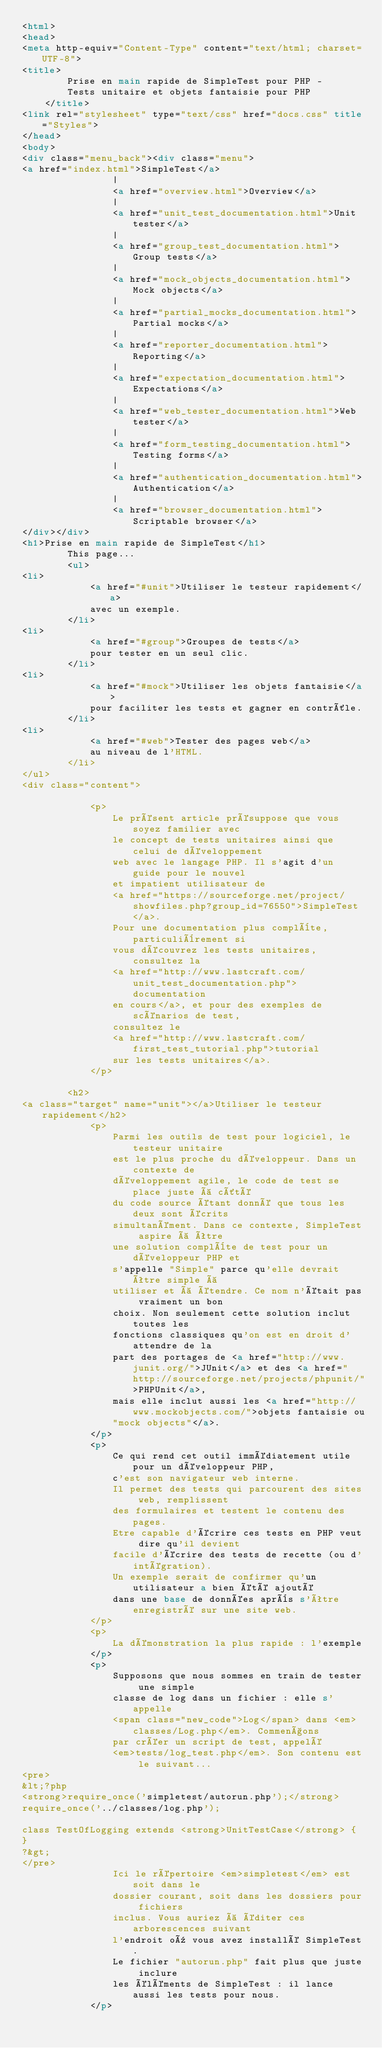Convert code to text. <code><loc_0><loc_0><loc_500><loc_500><_HTML_><html>
<head>
<meta http-equiv="Content-Type" content="text/html; charset=UTF-8">
<title>
        Prise en main rapide de SimpleTest pour PHP -
        Tests unitaire et objets fantaisie pour PHP
    </title>
<link rel="stylesheet" type="text/css" href="docs.css" title="Styles">
</head>
<body>
<div class="menu_back"><div class="menu">
<a href="index.html">SimpleTest</a>
                |
                <a href="overview.html">Overview</a>
                |
                <a href="unit_test_documentation.html">Unit tester</a>
                |
                <a href="group_test_documentation.html">Group tests</a>
                |
                <a href="mock_objects_documentation.html">Mock objects</a>
                |
                <a href="partial_mocks_documentation.html">Partial mocks</a>
                |
                <a href="reporter_documentation.html">Reporting</a>
                |
                <a href="expectation_documentation.html">Expectations</a>
                |
                <a href="web_tester_documentation.html">Web tester</a>
                |
                <a href="form_testing_documentation.html">Testing forms</a>
                |
                <a href="authentication_documentation.html">Authentication</a>
                |
                <a href="browser_documentation.html">Scriptable browser</a>
</div></div>
<h1>Prise en main rapide de SimpleTest</h1>
        This page...
        <ul>
<li>
            <a href="#unit">Utiliser le testeur rapidement</a>
            avec un exemple.
        </li>
<li>
            <a href="#group">Groupes de tests</a>
            pour tester en un seul clic.
        </li>
<li>
            <a href="#mock">Utiliser les objets fantaisie</a>
            pour faciliter les tests et gagner en contrôle.
        </li>
<li>
            <a href="#web">Tester des pages web</a>
            au niveau de l'HTML.
        </li>
</ul>
<div class="content">
        
            <p>
                Le présent article présuppose que vous soyez familier avec
                le concept de tests unitaires ainsi que celui de développement
                web avec le langage PHP. Il s'agit d'un guide pour le nouvel
                et impatient utilisateur de
                <a href="https://sourceforge.net/project/showfiles.php?group_id=76550">SimpleTest</a>.
                Pour une documentation plus complète, particulièrement si
                vous découvrez les tests unitaires, consultez la
                <a href="http://www.lastcraft.com/unit_test_documentation.php">documentation
                en cours</a>, et pour des exemples de scénarios de test,
                consultez le
                <a href="http://www.lastcraft.com/first_test_tutorial.php">tutorial
                sur les tests unitaires</a>.
            </p>
        
        <h2>
<a class="target" name="unit"></a>Utiliser le testeur rapidement</h2>
            <p>
                Parmi les outils de test pour logiciel, le testeur unitaire
                est le plus proche du développeur. Dans un contexte de
                développement agile, le code de test se place juste à côté
                du code source étant donné que tous les deux sont écrits
                simultanément. Dans ce contexte, SimpleTest aspire à être
                une solution complète de test pour un développeur PHP et
                s'appelle "Simple" parce qu'elle devrait être simple à
                utiliser et à étendre. Ce nom n'était pas vraiment un bon
                choix. Non seulement cette solution inclut toutes les
                fonctions classiques qu'on est en droit d'attendre de la
                part des portages de <a href="http://www.junit.org/">JUnit</a> et des <a href="http://sourceforge.net/projects/phpunit/">PHPUnit</a>,
                mais elle inclut aussi les <a href="http://www.mockobjects.com/">objets fantaisie ou
                "mock objects"</a>.
            </p>
            <p>
                Ce qui rend cet outil immédiatement utile pour un développeur PHP,
                c'est son navigateur web interne.
                Il permet des tests qui parcourent des sites web, remplissent
                des formulaires et testent le contenu des pages.
                Etre capable d'écrire ces tests en PHP veut dire qu'il devient
                facile d'écrire des tests de recette (ou d'intégration).
                Un exemple serait de confirmer qu'un utilisateur a bien été ajouté
                dans une base de données après s'être enregistré sur une site web.
            </p>
            <p>
                La démonstration la plus rapide : l'exemple
            </p>
            <p>
                Supposons que nous sommes en train de tester une simple
                classe de log dans un fichier : elle s'appelle
                <span class="new_code">Log</span> dans <em>classes/Log.php</em>. Commençons
                par créer un script de test, appelé
                <em>tests/log_test.php</em>. Son contenu est le suivant...
<pre>
&lt;?php
<strong>require_once('simpletest/autorun.php');</strong>
require_once('../classes/log.php');

class TestOfLogging extends <strong>UnitTestCase</strong> {
}
?&gt;
</pre>
                Ici le répertoire <em>simpletest</em> est soit dans le
                dossier courant, soit dans les dossiers pour fichiers
                inclus. Vous auriez à éditer ces arborescences suivant
                l'endroit où vous avez installé SimpleTest.
                Le fichier "autorun.php" fait plus que juste inclure
                les éléments de SimpleTest : il lance aussi les tests pour nous.  
            </p></code> 